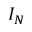Convert formula to latex. <formula><loc_0><loc_0><loc_500><loc_500>I _ { N }</formula> 